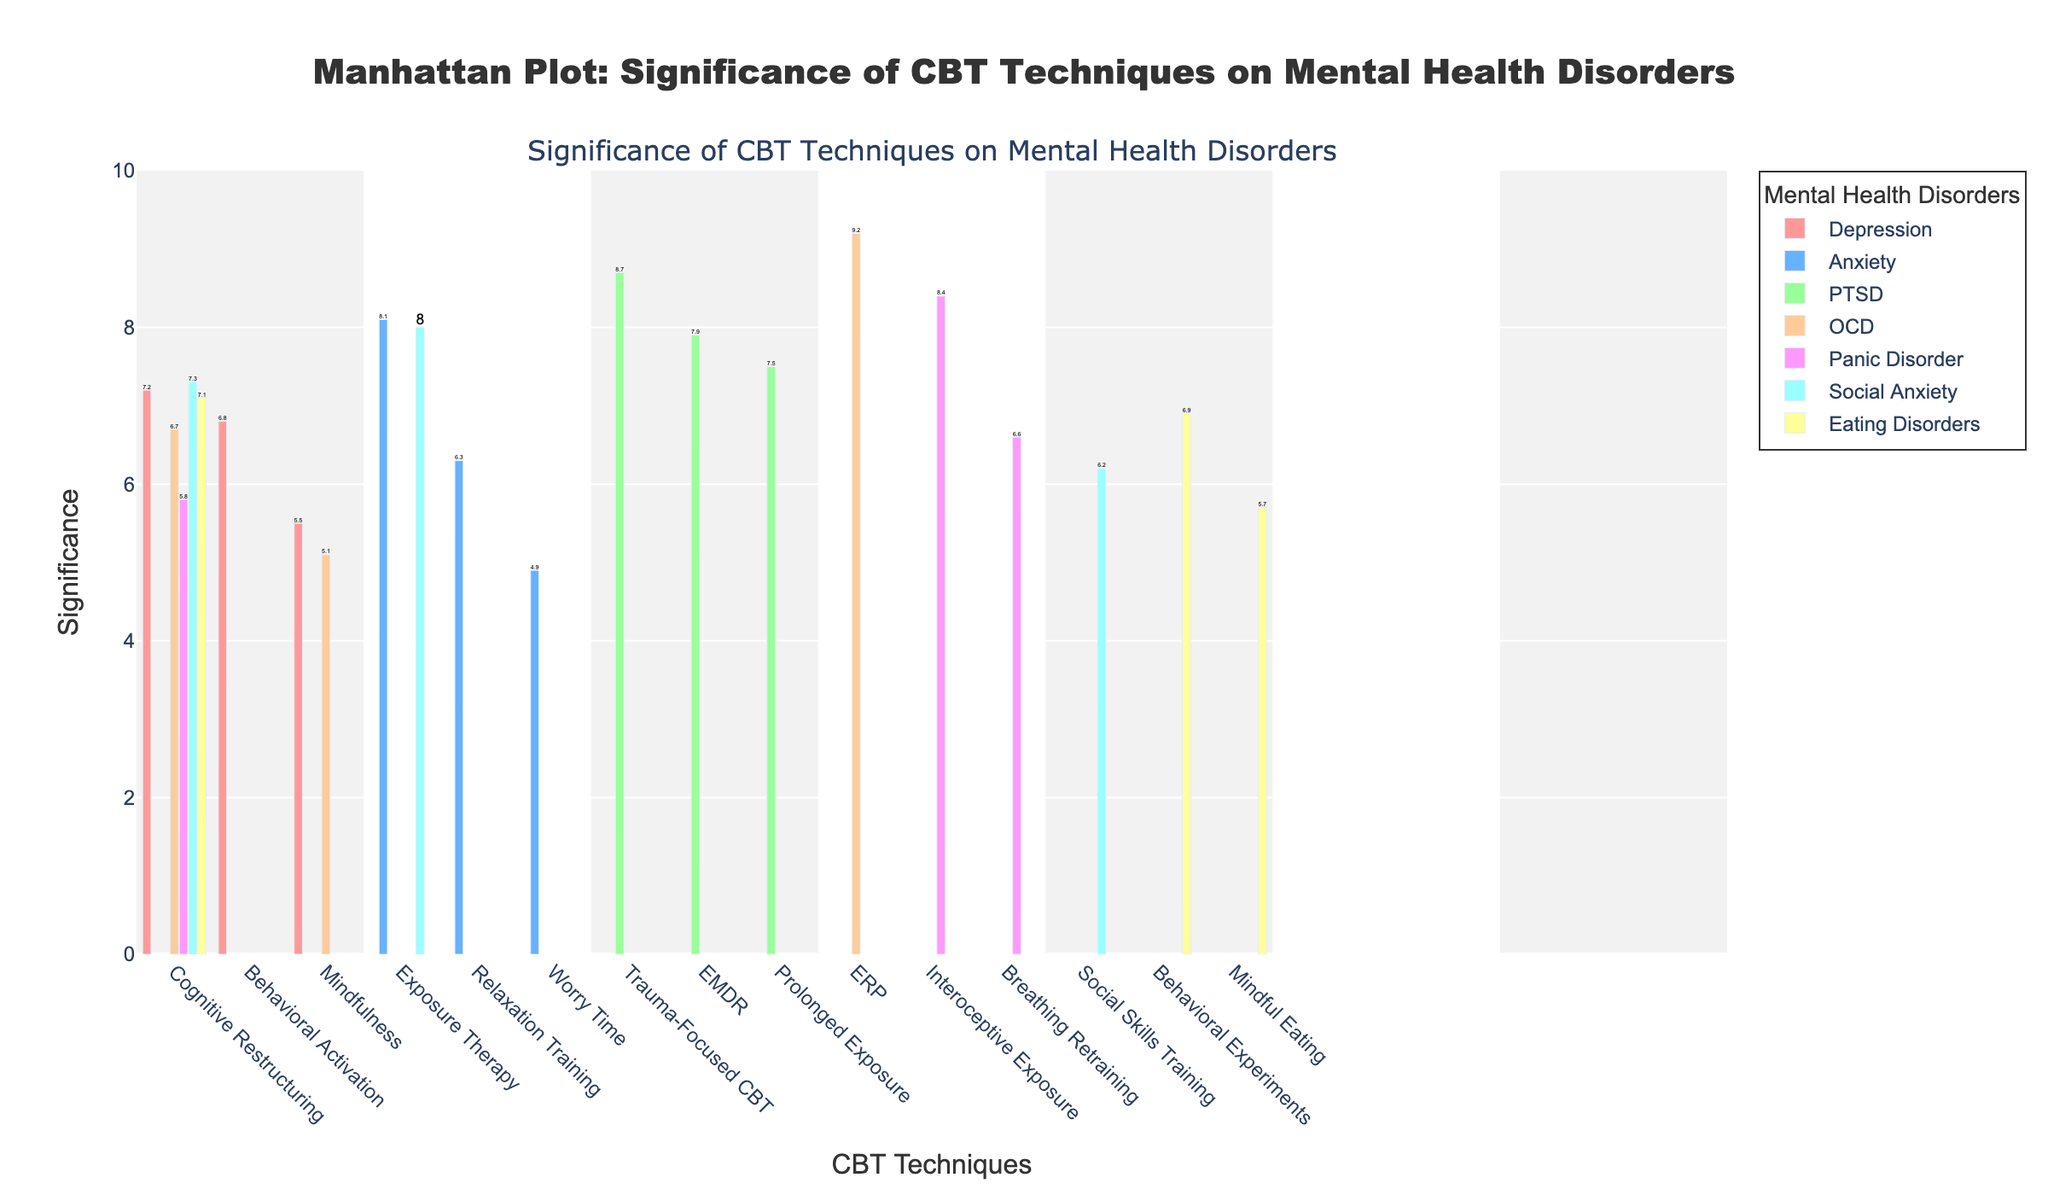Which CBT technique has the highest significance for OCD? First, identify the group for OCD. Then, find the technique with the highest significance within this group. ERP has the highest significance in the OCD group.
Answer: ERP Which mental health disorder has the highest significance for Cognitive Restructuring? Look at the techniques titled Cognitive Restructuring across all disorders and compare their significance values. Social Anxiety has the highest significance for Cognitive Restructuring.
Answer: Social Anxiety What's the difference in significance between Exposure Therapy for Anxiety and Social Anxiety? Find the significance values for Exposure Therapy in both Anxiety and Social Anxiety. Subtract the smaller value from the larger one. The difference is 8.0 - 8.1 = -0.1.
Answer: -0.1 How many CBT techniques are listed for Panic Disorder? Count the number of CBT techniques within the group for Panic Disorder. There are three techniques listed: Interoceptive Exposure, Breathing Retraining, and Cognitive Restructuring.
Answer: 3 Which disorder shows the highest overall significance value? Scan all significance values across disorders and find the highest value. OCD with ERP shows the highest significance value of 9.2.
Answer: OCD Compare the significances of all techniques for Depression. Which one has the lowest significance? Look at all techniques listed under Depression and note their significance values. Mindfulness has the lowest significance value of 5.5.
Answer: Mindfulness Is the average significance of techniques for Eating Disorders greater than 6.0? Calculate the average significance of the three techniques for Eating Disorders: (7.1 + 6.9 + 5.7) / 3 = 6.57, which is greater than 6.0.
Answer: Yes Which technique has a higher significance for PTSD, Trauma-Focused CBT or EMDR? Compare the significance values of Trauma-Focused CBT and EMDR for PTSD. Trauma-Focused CBT has a higher significance (8.7) than EMDR (7.9).
Answer: Trauma-Focused CBT How does the significance of Behavior Activation for Depression compare to that of Breathing Retraining for Panic Disorder? Compare the significance values of Behavioral Activation for Depression and Breathing Retraining for Panic Disorder. Behavioral Activation for Depression has a significance of 6.8, while Breathing Retraining for Panic Disorder has a lower significance of 6.6.
Answer: Behavioral Activation Are any techniques for Anxiety below a significance of 5.0? Identify and check all significance values for techniques listed under Anxiety. Worry Time has a significance of 4.9, which is below 5.0.
Answer: Yes 